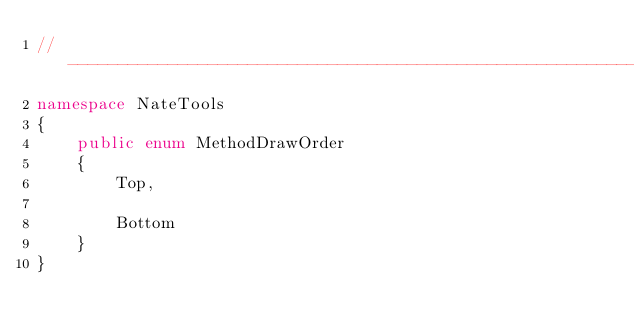<code> <loc_0><loc_0><loc_500><loc_500><_C#_>//  --------------------------------------------------------------------------------------------------------------------
namespace NateTools
{
    public enum MethodDrawOrder
    {
        Top,

        Bottom
    }
}</code> 